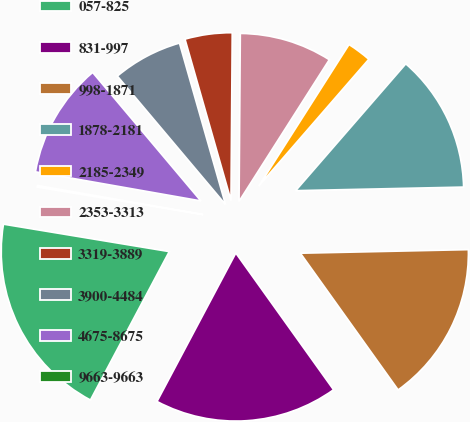Convert chart to OTSL. <chart><loc_0><loc_0><loc_500><loc_500><pie_chart><fcel>057-825<fcel>831-997<fcel>998-1871<fcel>1878-2181<fcel>2185-2349<fcel>2353-3313<fcel>3319-3889<fcel>3900-4484<fcel>4675-8675<fcel>9663-9663<nl><fcel>19.84%<fcel>17.65%<fcel>15.46%<fcel>13.28%<fcel>2.35%<fcel>8.91%<fcel>4.54%<fcel>6.72%<fcel>11.09%<fcel>0.16%<nl></chart> 